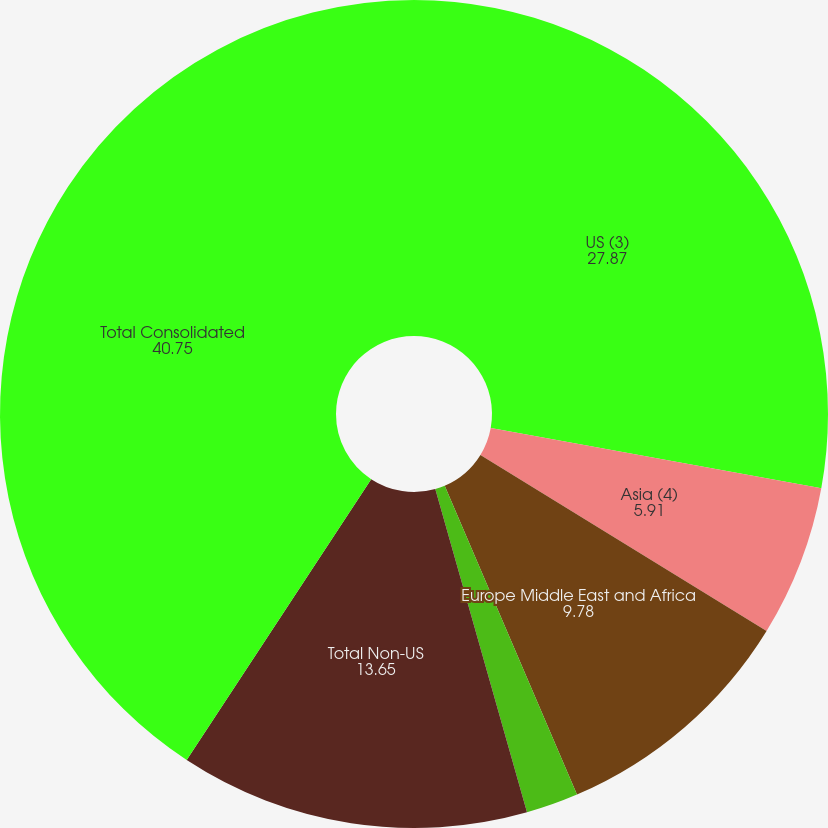Convert chart. <chart><loc_0><loc_0><loc_500><loc_500><pie_chart><fcel>US (3)<fcel>Asia (4)<fcel>Europe Middle East and Africa<fcel>Latin America and the<fcel>Total Non-US<fcel>Total Consolidated<nl><fcel>27.87%<fcel>5.91%<fcel>9.78%<fcel>2.04%<fcel>13.65%<fcel>40.75%<nl></chart> 